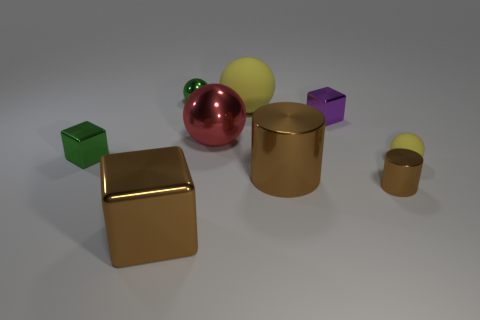Does this image appear to be photorealistic or computer-generated? The image seems to be computer-generated, as indicated by the perfect shapes and even colors of the objects, along with the clean environment and harmoniously placed shadows. 